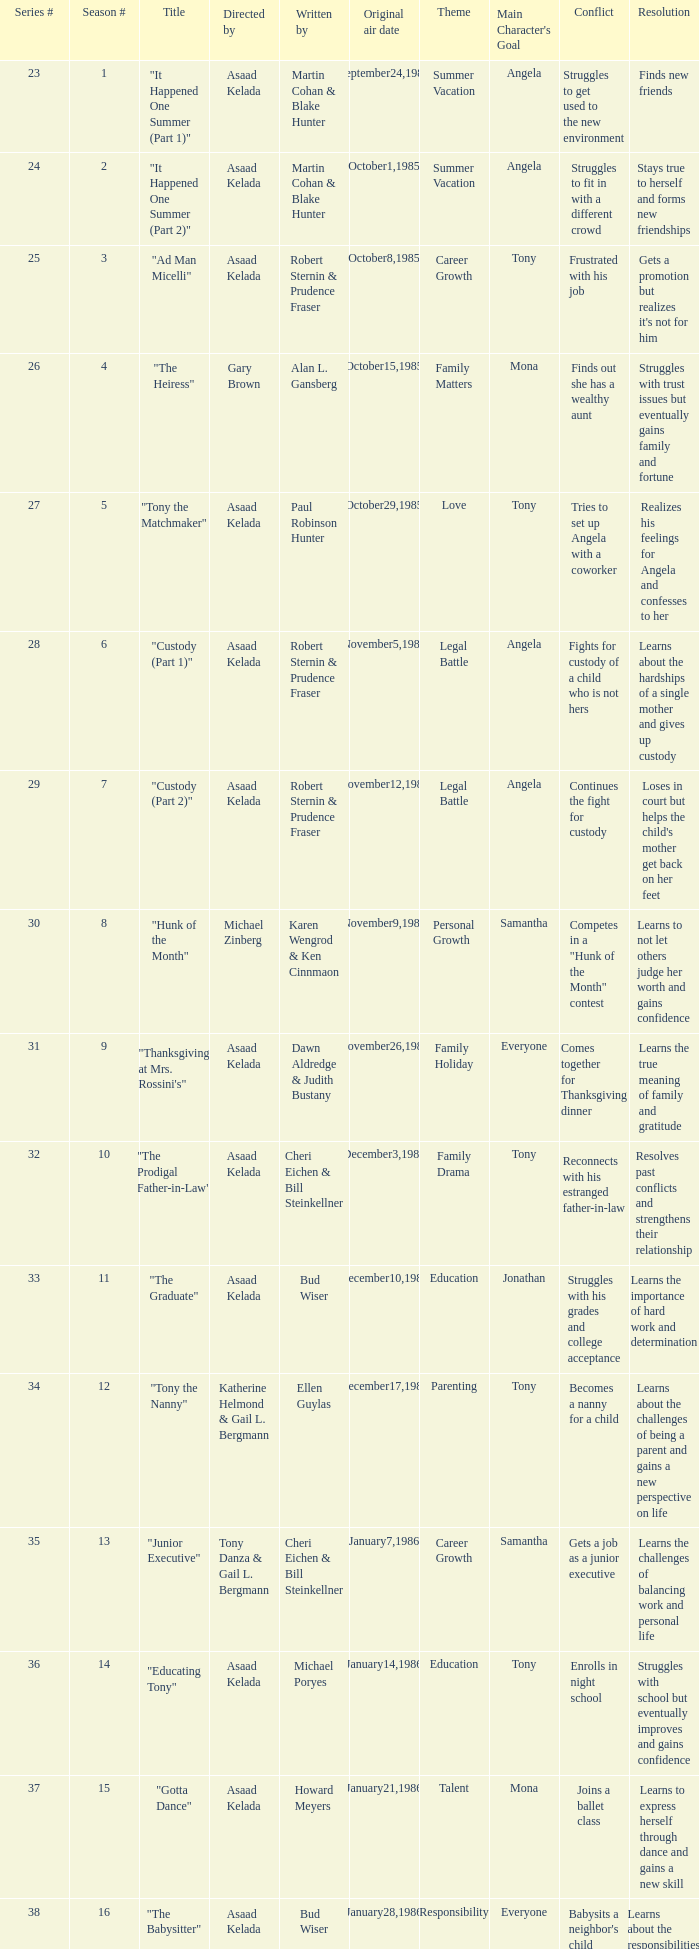What is the date of the episode written by Michael Poryes? January14,1986. 